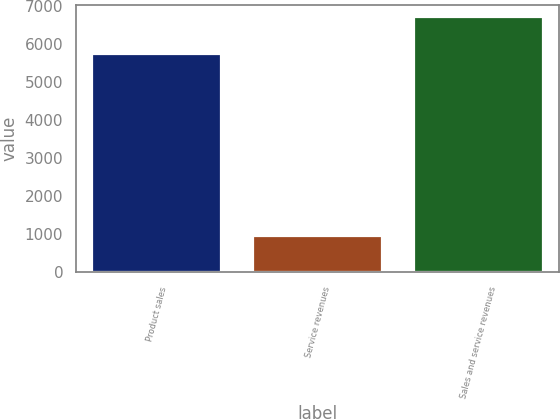Convert chart to OTSL. <chart><loc_0><loc_0><loc_500><loc_500><bar_chart><fcel>Product sales<fcel>Service revenues<fcel>Sales and service revenues<nl><fcel>5755<fcel>953<fcel>6708<nl></chart> 